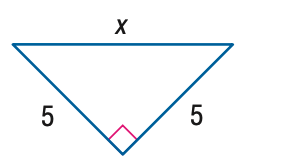Answer the mathemtical geometry problem and directly provide the correct option letter.
Question: Find x.
Choices: A: 5 B: 5 \sqrt { 2 } C: 5 \sqrt { 3 } D: 10 B 